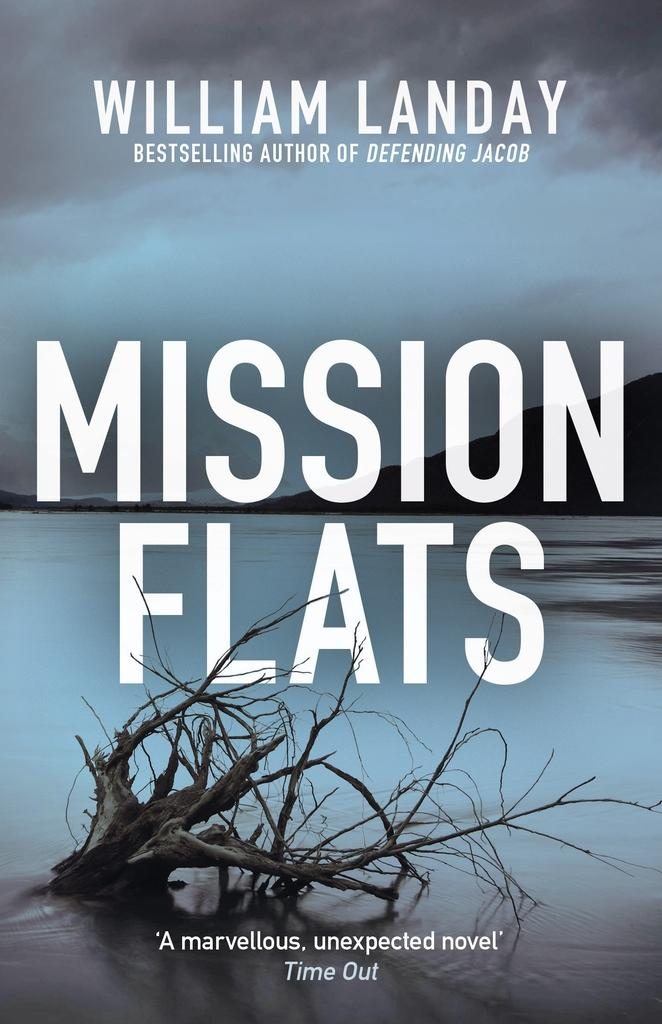<image>
Share a concise interpretation of the image provided. A book titled Mission Flat shows a calm river with a tree branch sticking out of the water 